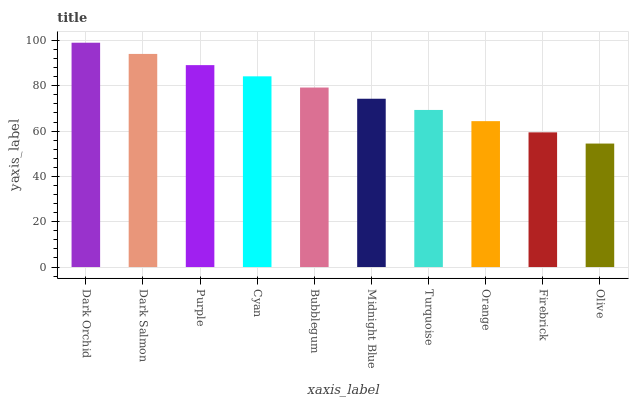Is Olive the minimum?
Answer yes or no. Yes. Is Dark Orchid the maximum?
Answer yes or no. Yes. Is Dark Salmon the minimum?
Answer yes or no. No. Is Dark Salmon the maximum?
Answer yes or no. No. Is Dark Orchid greater than Dark Salmon?
Answer yes or no. Yes. Is Dark Salmon less than Dark Orchid?
Answer yes or no. Yes. Is Dark Salmon greater than Dark Orchid?
Answer yes or no. No. Is Dark Orchid less than Dark Salmon?
Answer yes or no. No. Is Bubblegum the high median?
Answer yes or no. Yes. Is Midnight Blue the low median?
Answer yes or no. Yes. Is Dark Orchid the high median?
Answer yes or no. No. Is Olive the low median?
Answer yes or no. No. 